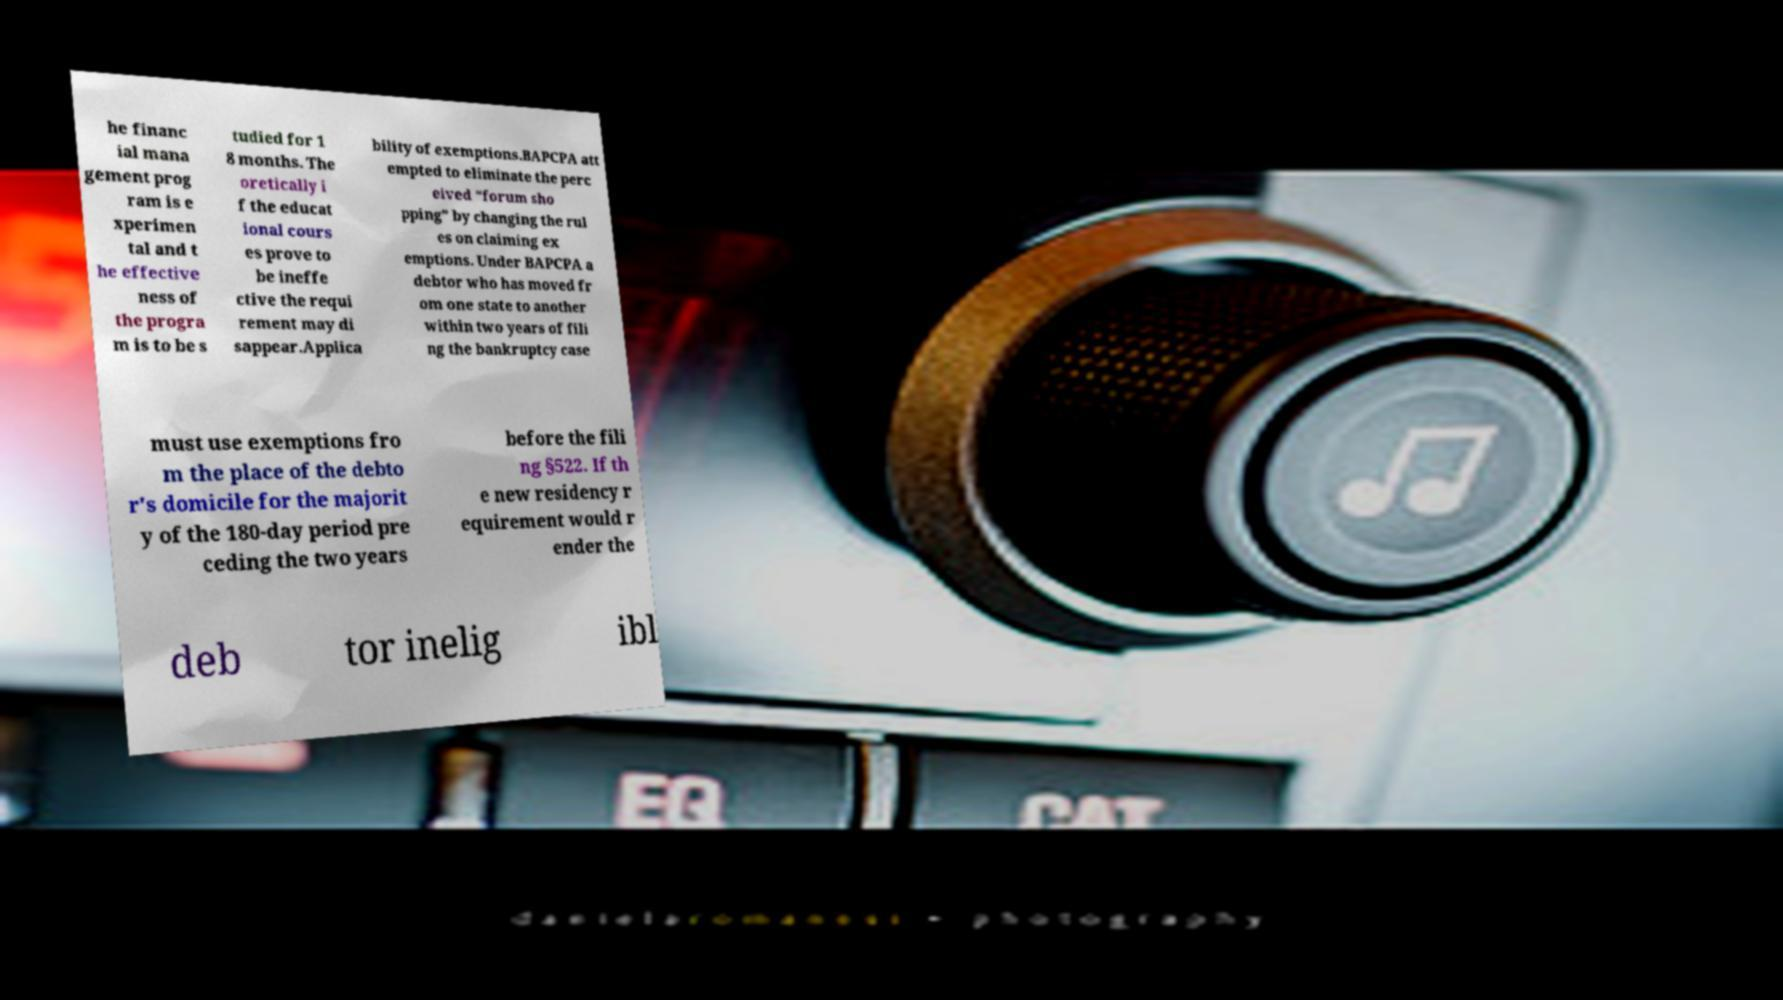Please read and relay the text visible in this image. What does it say? he financ ial mana gement prog ram is e xperimen tal and t he effective ness of the progra m is to be s tudied for 1 8 months. The oretically i f the educat ional cours es prove to be ineffe ctive the requi rement may di sappear.Applica bility of exemptions.BAPCPA att empted to eliminate the perc eived “forum sho pping” by changing the rul es on claiming ex emptions. Under BAPCPA a debtor who has moved fr om one state to another within two years of fili ng the bankruptcy case must use exemptions fro m the place of the debto r's domicile for the majorit y of the 180-day period pre ceding the two years before the fili ng §522. If th e new residency r equirement would r ender the deb tor inelig ibl 